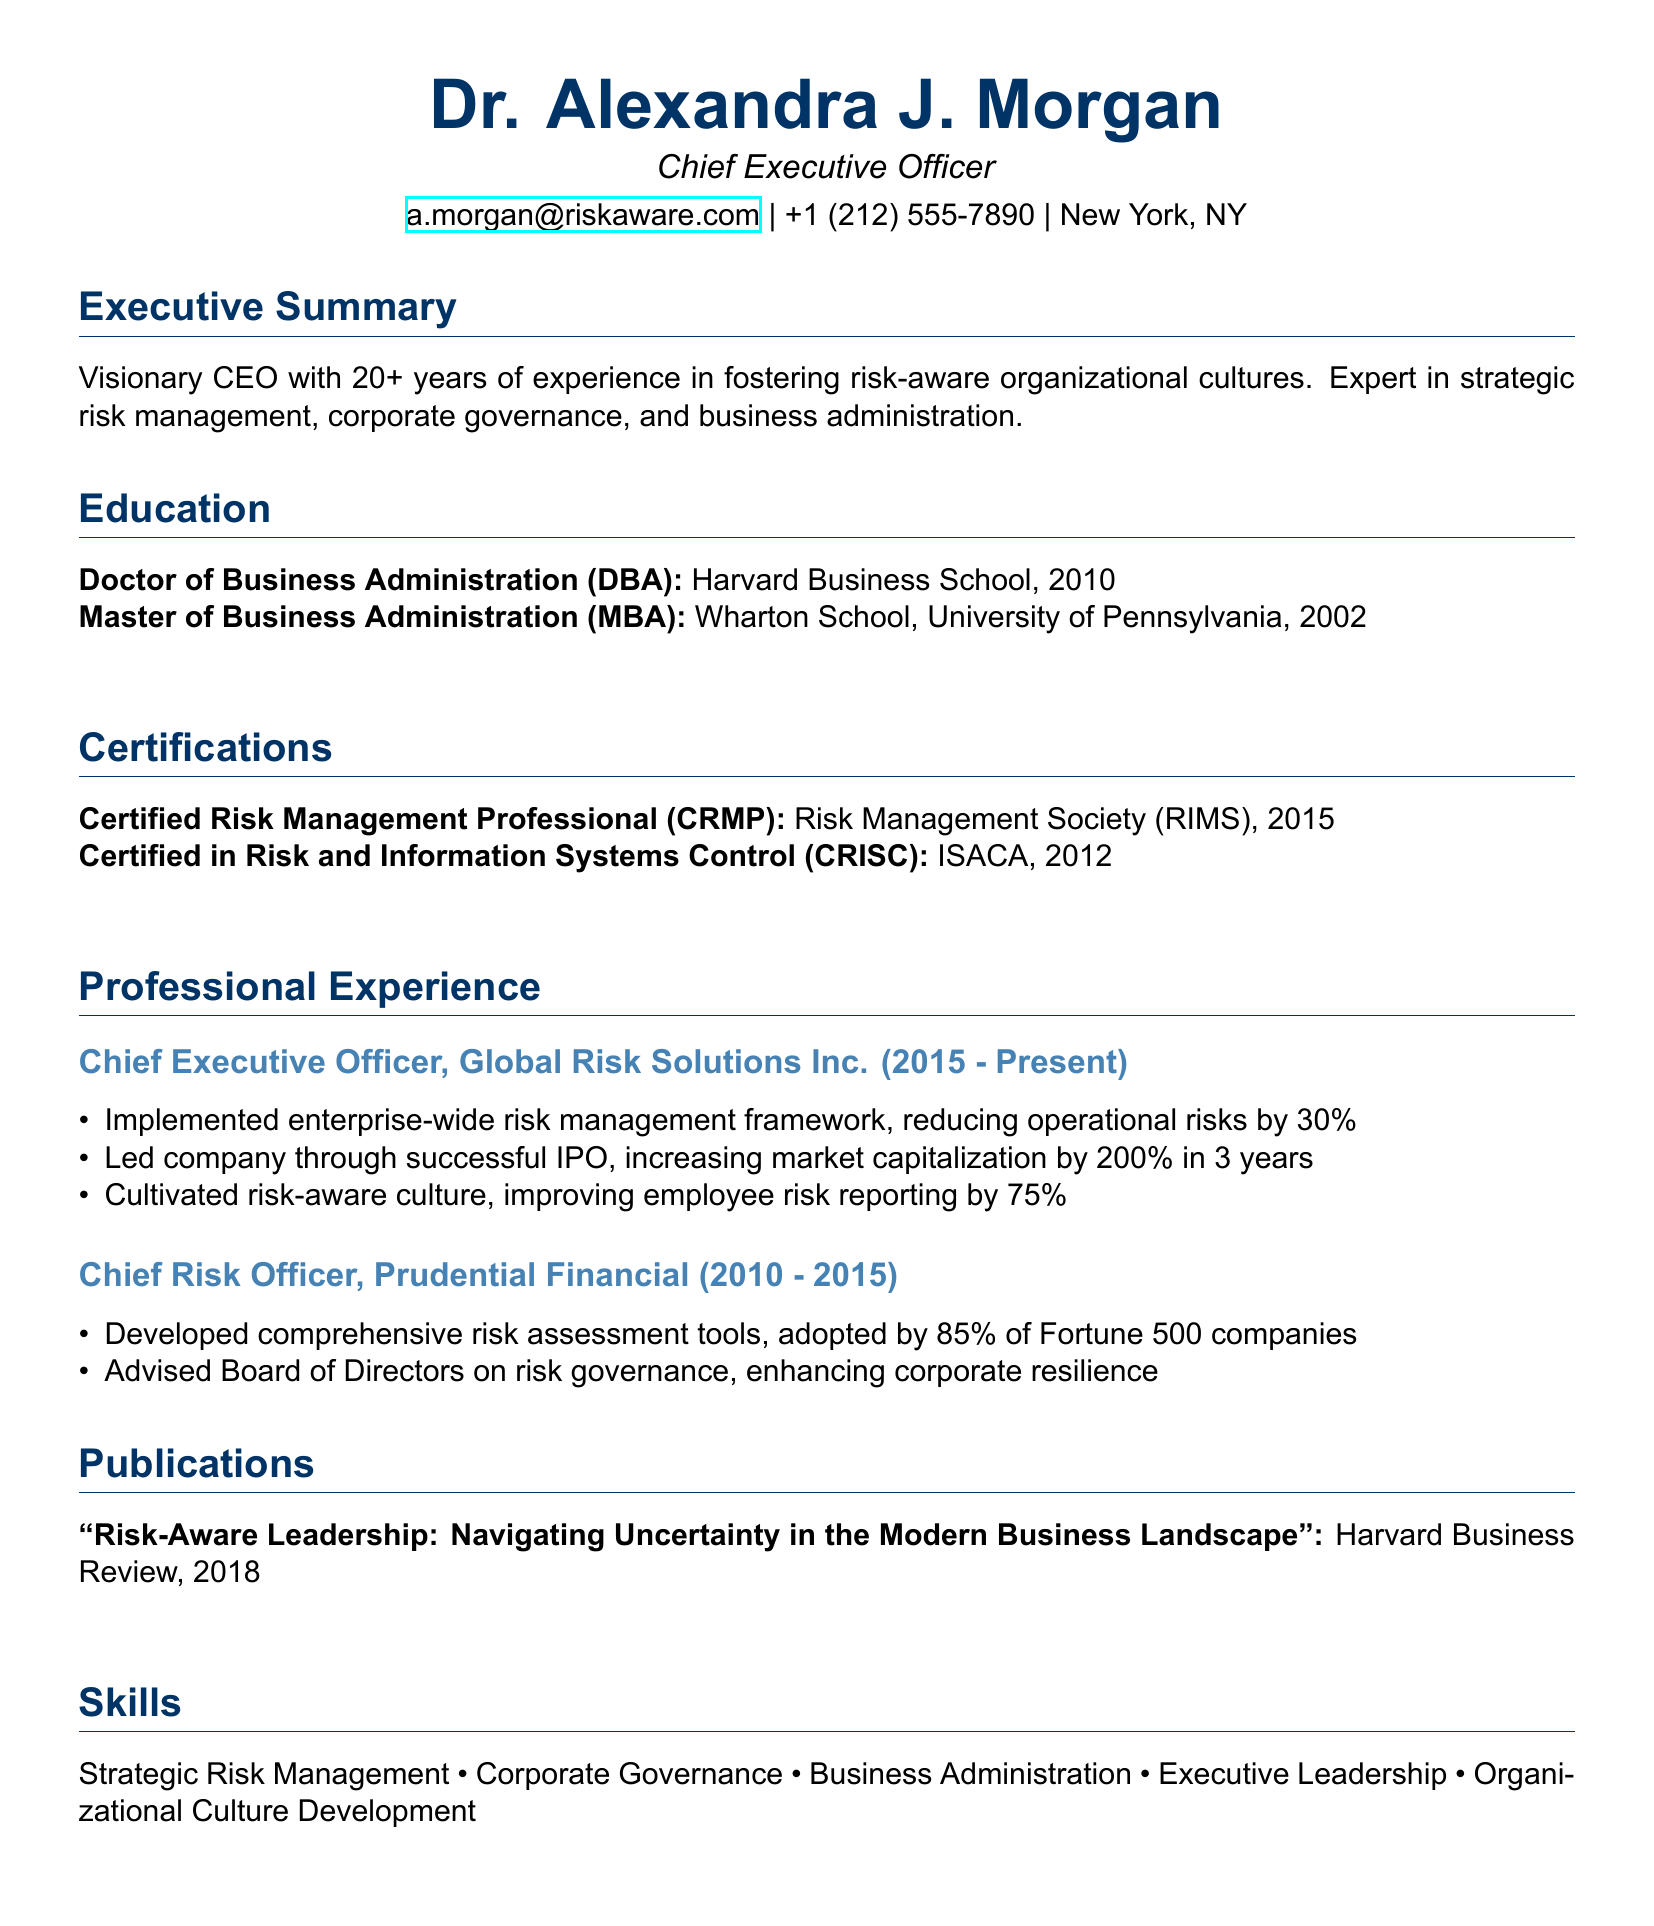What is the name of the CEO? The document states the name of the CEO is Dr. Alexandra J. Morgan.
Answer: Dr. Alexandra J. Morgan What is the highest degree obtained by Alexandra? The document lists her highest degree as Doctor of Business Administration (DBA) from Harvard Business School.
Answer: Doctor of Business Administration (DBA) What year did Alexandra achieve her MBA? The information indicates she completed her MBA in 2002.
Answer: 2002 How long has Alexandra been the CEO of Global Risk Solutions Inc.? The document states she has held this position from 2015 to Present, suggesting approximately 8 years.
Answer: 8 years What is one of her key achievements as CEO? Among her achievements, she implemented an enterprise-wide risk management framework that reduced operational risks by 30%.
Answer: Reduced operational risks by 30% Which certification was obtained in 2015? The document lists the Certified Risk Management Professional (CRMP) certification as achieved in 2015.
Answer: Certified Risk Management Professional (CRMP) How many years of experience does Alexandra have in her field? The executive summary mentions she has over 20 years of experience in fostering risk-aware organizational cultures.
Answer: 20+ Who published her article on risk management? The publication section states her article was published by Harvard Business Review.
Answer: Harvard Business Review What skill is emphasized in Alexandra's profile? The skills section lists "Strategic Risk Management" as a key emphasis of her profile.
Answer: Strategic Risk Management 